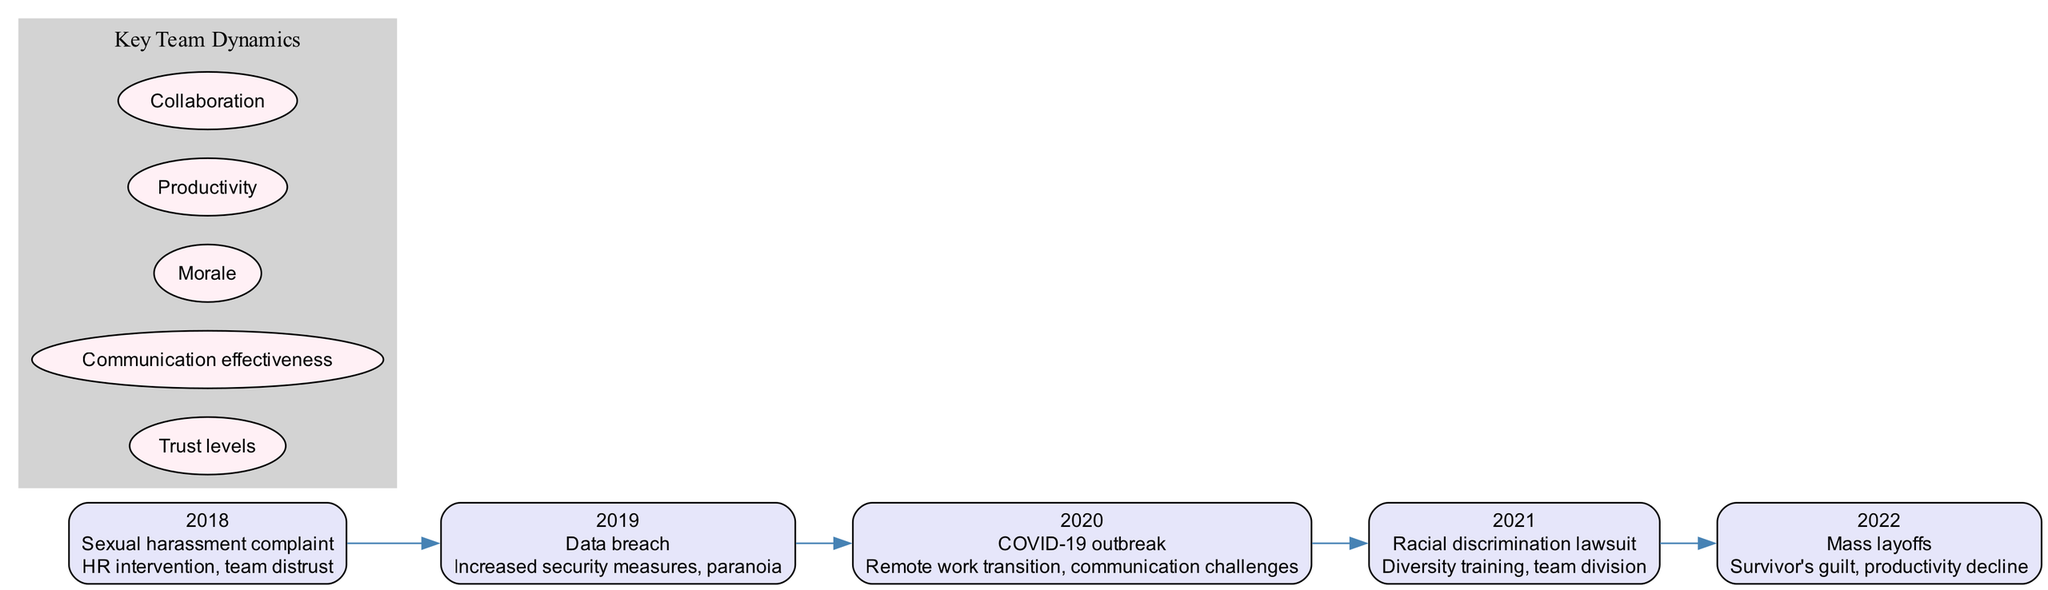What year did the sexual harassment complaint occur? The diagram shows a timeline that lists years along with corresponding events. The node for the "Sexual harassment complaint" is labeled with the year 2018.
Answer: 2018 What was the impact of the COVID-19 outbreak? The timeline provides details about each event and its impact. The event "COVID-19 outbreak" indicates the impact as "Remote work transition, communication challenges."
Answer: Remote work transition, communication challenges How many workplace incidents are listed in the timeline? By counting the number of distinct events presented in the timeline, we find five events: sexual harassment complaint, data breach, COVID-19 outbreak, racial discrimination lawsuit, and mass layoffs.
Answer: 5 What was the primary team dynamic affected by the racial discrimination lawsuit? The diagram indicates that the event "Racial discrimination lawsuit" led to "Diversity training, team division." This suggests that team division was a specific team dynamic affected.
Answer: Team division Which incident resulted in increased security measures? Referring to the timeline, the event associated with increased security measures is the "Data breach." This is clearly stated in the impact section of that event.
Answer: Data breach What is the relationship between the incident of mass layoffs and productivity? Based on the timeline's impact for "Mass layoffs," it states "Survivor's guilt, productivity decline," indicating a direct relationship where layoffs negatively impacted productivity.
Answer: Productivity decline What are the key team dynamics listed in the diagram? The diagram's subgraph includes five nodes titled "Trust levels," "Communication effectiveness," "Morale," "Productivity," and "Collaboration." These describe the key dynamics affected by incidents.
Answer: Trust levels, Communication effectiveness, Morale, Productivity, Collaboration In which year did the mass layoffs occur? The event "Mass layoffs" is found in the timeline labeled with the year 2022, indicating when this incident took place.
Answer: 2022 How did the sexual harassment complaint affect team dynamics? The timeline states that the impact of the "Sexual harassment complaint" was "HR intervention, team distrust," reflecting the specific team dynamics that were affected.
Answer: Team distrust 